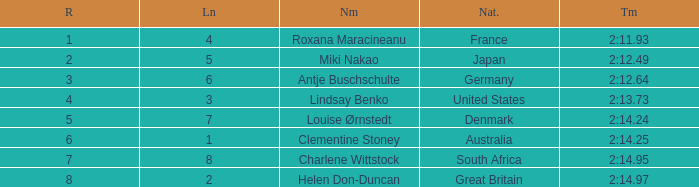What shows for nationality when there is a rank larger than 6, and a Time of 2:14.95? South Africa. 